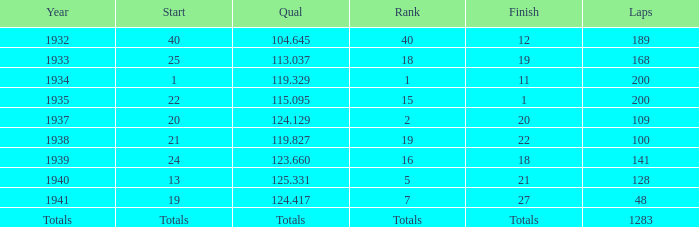With a qualification score of 123.660, what was the concluding rank? 18.0. 